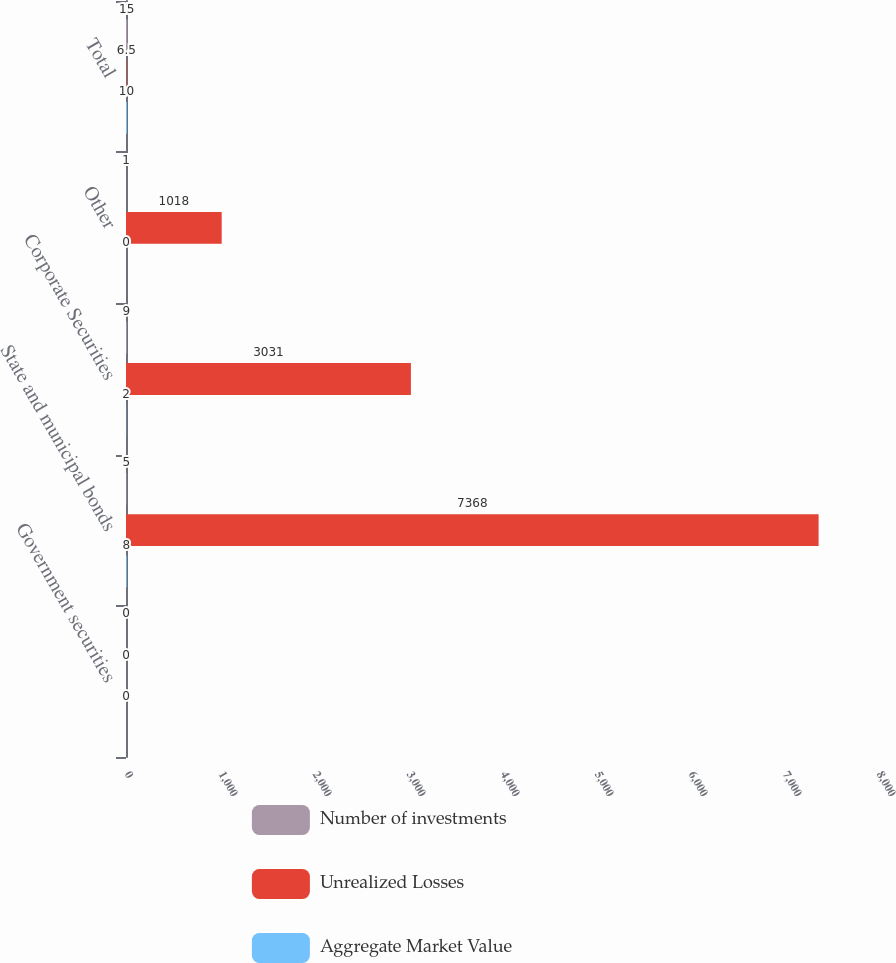Convert chart to OTSL. <chart><loc_0><loc_0><loc_500><loc_500><stacked_bar_chart><ecel><fcel>Government securities<fcel>State and municipal bonds<fcel>Corporate Securities<fcel>Other<fcel>Total<nl><fcel>Number of investments<fcel>0<fcel>5<fcel>9<fcel>1<fcel>15<nl><fcel>Unrealized Losses<fcel>0<fcel>7368<fcel>3031<fcel>1018<fcel>6.5<nl><fcel>Aggregate Market Value<fcel>0<fcel>8<fcel>2<fcel>0<fcel>10<nl></chart> 